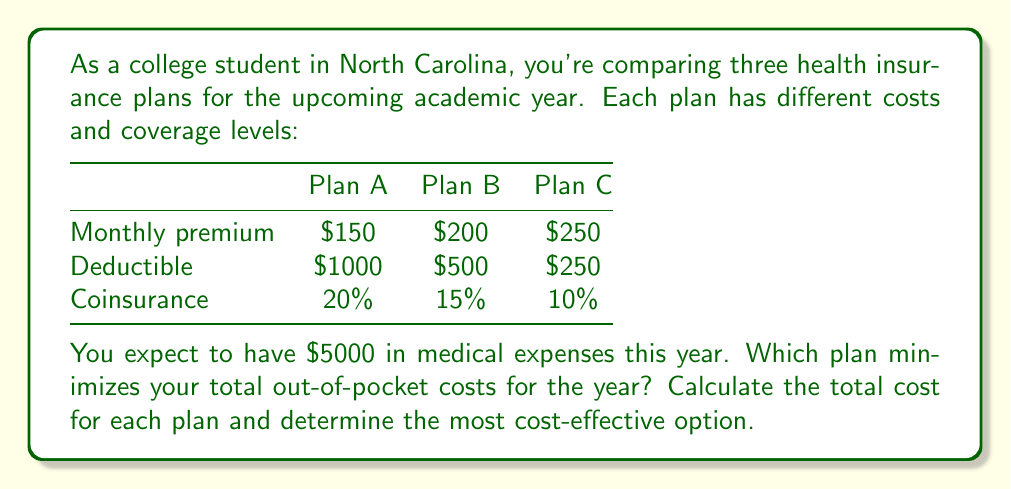Show me your answer to this math problem. To solve this problem, we need to calculate the total cost for each plan using the given information. The total cost consists of the annual premium, the deductible, and the coinsurance on the remaining expenses.

Let's calculate for each plan:

1. Plan A:
   Annual premium: $150 × 12 = $1800
   Deductible: $1000
   Remaining expenses: $5000 - $1000 = $4000
   Coinsurance: 20% of $4000 = $800
   Total cost: $1800 + $1000 + $800 = $3600

2. Plan B:
   Annual premium: $200 × 12 = $2400
   Deductible: $500
   Remaining expenses: $5000 - $500 = $4500
   Coinsurance: 15% of $4500 = $675
   Total cost: $2400 + $500 + $675 = $3575

3. Plan C:
   Annual premium: $250 × 12 = $3000
   Deductible: $250
   Remaining expenses: $5000 - $250 = $4750
   Coinsurance: 10% of $4750 = $475
   Total cost: $3000 + $250 + $475 = $3725

To formalize this calculation, we can use the following equation for each plan:

$$\text{Total Cost} = (\text{Monthly Premium} \times 12) + \text{Deductible} + (\text{Coinsurance Rate} \times (\text{Expected Expenses} - \text{Deductible}))$$

Comparing the total costs:
Plan A: $3600
Plan B: $3575
Plan C: $3725

Therefore, Plan B is the most cost-effective option, minimizing the total out-of-pocket costs for the year.
Answer: Plan B with a total cost of $3575 is the most cost-effective option. 